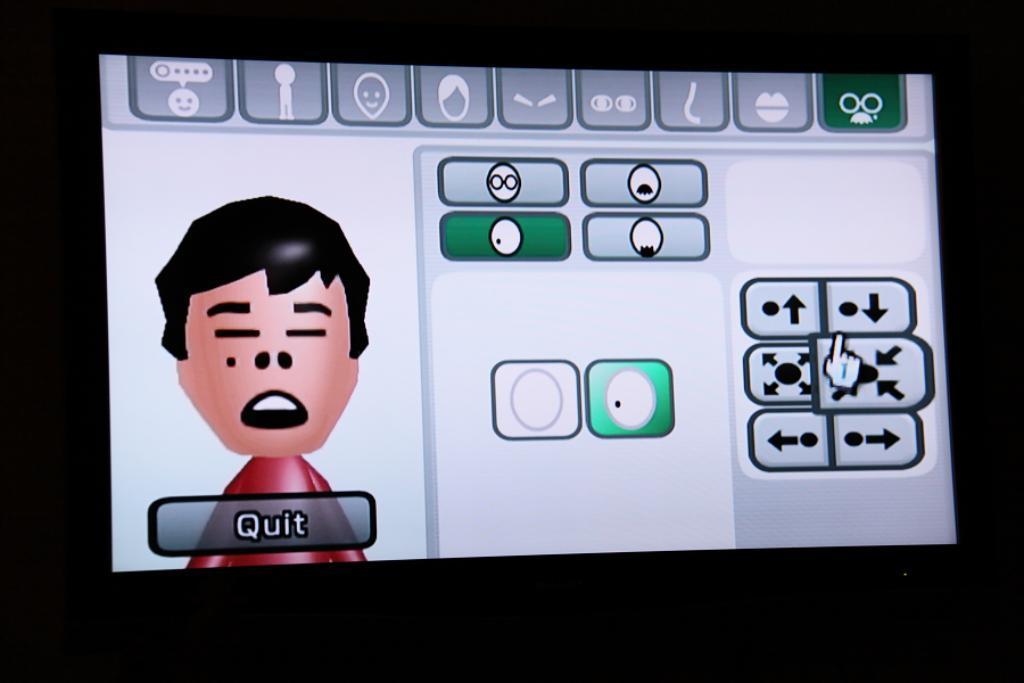How would you summarize this image in a sentence or two? This image is an animated image in which there are symbols and there is the cartoon image and there is some text written. 